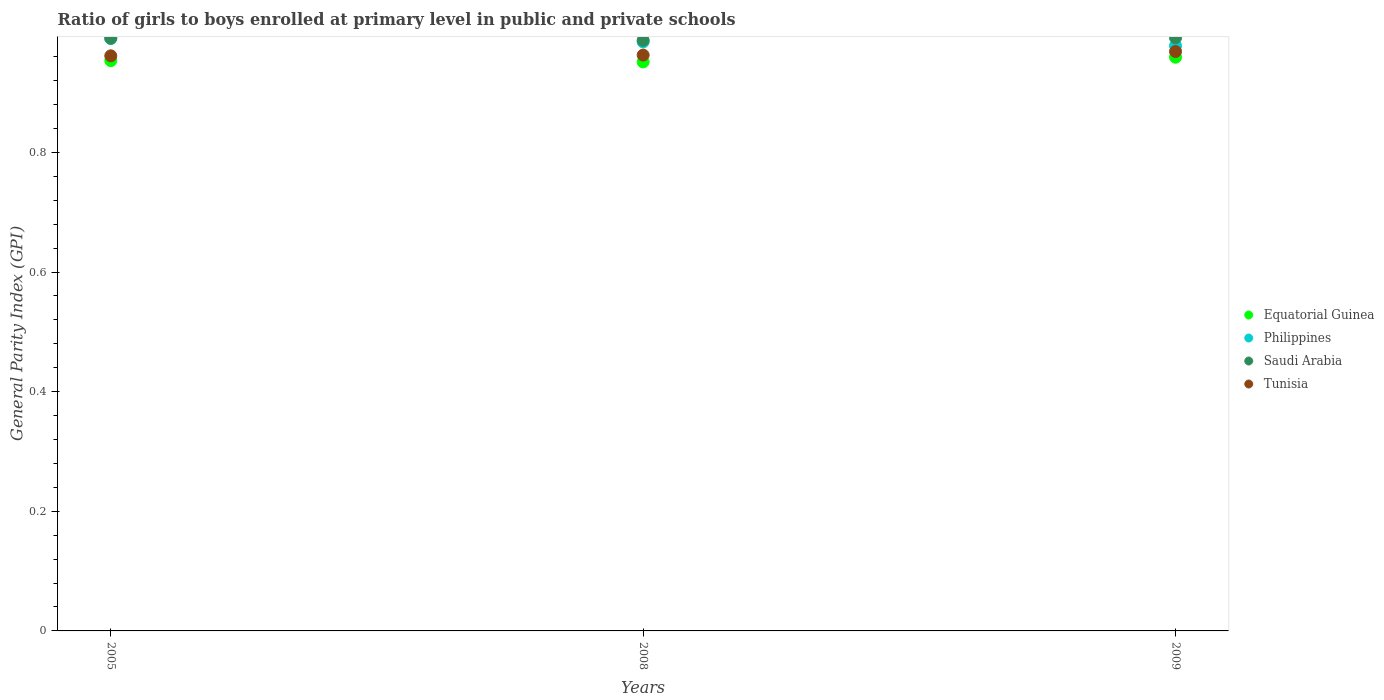How many different coloured dotlines are there?
Your response must be concise. 4. What is the general parity index in Saudi Arabia in 2005?
Your answer should be compact. 0.99. Across all years, what is the maximum general parity index in Philippines?
Your answer should be very brief. 0.99. Across all years, what is the minimum general parity index in Philippines?
Offer a terse response. 0.98. In which year was the general parity index in Equatorial Guinea minimum?
Keep it short and to the point. 2008. What is the total general parity index in Equatorial Guinea in the graph?
Provide a short and direct response. 2.86. What is the difference between the general parity index in Saudi Arabia in 2008 and that in 2009?
Your answer should be compact. -0. What is the difference between the general parity index in Philippines in 2005 and the general parity index in Equatorial Guinea in 2009?
Provide a succinct answer. 0.03. What is the average general parity index in Saudi Arabia per year?
Your response must be concise. 0.99. In the year 2005, what is the difference between the general parity index in Saudi Arabia and general parity index in Tunisia?
Your response must be concise. 0.03. In how many years, is the general parity index in Tunisia greater than 0.44?
Give a very brief answer. 3. What is the ratio of the general parity index in Tunisia in 2005 to that in 2008?
Ensure brevity in your answer.  1. What is the difference between the highest and the second highest general parity index in Saudi Arabia?
Make the answer very short. 0. What is the difference between the highest and the lowest general parity index in Equatorial Guinea?
Make the answer very short. 0.01. Is the sum of the general parity index in Philippines in 2005 and 2009 greater than the maximum general parity index in Tunisia across all years?
Your answer should be very brief. Yes. Is it the case that in every year, the sum of the general parity index in Tunisia and general parity index in Equatorial Guinea  is greater than the sum of general parity index in Saudi Arabia and general parity index in Philippines?
Make the answer very short. No. Is it the case that in every year, the sum of the general parity index in Equatorial Guinea and general parity index in Saudi Arabia  is greater than the general parity index in Philippines?
Ensure brevity in your answer.  Yes. Does the general parity index in Philippines monotonically increase over the years?
Offer a very short reply. No. Is the general parity index in Equatorial Guinea strictly greater than the general parity index in Saudi Arabia over the years?
Your answer should be compact. No. How many dotlines are there?
Your answer should be very brief. 4. How many years are there in the graph?
Your answer should be very brief. 3. Does the graph contain grids?
Give a very brief answer. No. Where does the legend appear in the graph?
Offer a terse response. Center right. What is the title of the graph?
Offer a very short reply. Ratio of girls to boys enrolled at primary level in public and private schools. What is the label or title of the X-axis?
Make the answer very short. Years. What is the label or title of the Y-axis?
Your answer should be very brief. General Parity Index (GPI). What is the General Parity Index (GPI) in Equatorial Guinea in 2005?
Give a very brief answer. 0.95. What is the General Parity Index (GPI) of Philippines in 2005?
Your answer should be very brief. 0.99. What is the General Parity Index (GPI) of Saudi Arabia in 2005?
Provide a short and direct response. 0.99. What is the General Parity Index (GPI) in Tunisia in 2005?
Ensure brevity in your answer.  0.96. What is the General Parity Index (GPI) of Equatorial Guinea in 2008?
Ensure brevity in your answer.  0.95. What is the General Parity Index (GPI) of Philippines in 2008?
Make the answer very short. 0.98. What is the General Parity Index (GPI) in Saudi Arabia in 2008?
Offer a very short reply. 0.99. What is the General Parity Index (GPI) in Tunisia in 2008?
Give a very brief answer. 0.96. What is the General Parity Index (GPI) in Equatorial Guinea in 2009?
Provide a succinct answer. 0.96. What is the General Parity Index (GPI) in Philippines in 2009?
Offer a very short reply. 0.98. What is the General Parity Index (GPI) in Saudi Arabia in 2009?
Keep it short and to the point. 0.99. What is the General Parity Index (GPI) in Tunisia in 2009?
Your answer should be compact. 0.97. Across all years, what is the maximum General Parity Index (GPI) of Equatorial Guinea?
Make the answer very short. 0.96. Across all years, what is the maximum General Parity Index (GPI) of Philippines?
Your response must be concise. 0.99. Across all years, what is the maximum General Parity Index (GPI) of Saudi Arabia?
Provide a short and direct response. 0.99. Across all years, what is the maximum General Parity Index (GPI) in Tunisia?
Make the answer very short. 0.97. Across all years, what is the minimum General Parity Index (GPI) of Equatorial Guinea?
Give a very brief answer. 0.95. Across all years, what is the minimum General Parity Index (GPI) of Philippines?
Provide a short and direct response. 0.98. Across all years, what is the minimum General Parity Index (GPI) of Saudi Arabia?
Give a very brief answer. 0.99. Across all years, what is the minimum General Parity Index (GPI) in Tunisia?
Provide a succinct answer. 0.96. What is the total General Parity Index (GPI) in Equatorial Guinea in the graph?
Give a very brief answer. 2.86. What is the total General Parity Index (GPI) in Philippines in the graph?
Ensure brevity in your answer.  2.95. What is the total General Parity Index (GPI) in Saudi Arabia in the graph?
Offer a very short reply. 2.97. What is the total General Parity Index (GPI) of Tunisia in the graph?
Your response must be concise. 2.89. What is the difference between the General Parity Index (GPI) in Equatorial Guinea in 2005 and that in 2008?
Make the answer very short. 0. What is the difference between the General Parity Index (GPI) in Philippines in 2005 and that in 2008?
Offer a terse response. 0.01. What is the difference between the General Parity Index (GPI) in Saudi Arabia in 2005 and that in 2008?
Keep it short and to the point. 0. What is the difference between the General Parity Index (GPI) in Tunisia in 2005 and that in 2008?
Provide a succinct answer. -0. What is the difference between the General Parity Index (GPI) in Equatorial Guinea in 2005 and that in 2009?
Offer a very short reply. -0.01. What is the difference between the General Parity Index (GPI) of Philippines in 2005 and that in 2009?
Ensure brevity in your answer.  0.01. What is the difference between the General Parity Index (GPI) of Saudi Arabia in 2005 and that in 2009?
Provide a succinct answer. -0. What is the difference between the General Parity Index (GPI) in Tunisia in 2005 and that in 2009?
Offer a very short reply. -0.01. What is the difference between the General Parity Index (GPI) in Equatorial Guinea in 2008 and that in 2009?
Give a very brief answer. -0.01. What is the difference between the General Parity Index (GPI) in Philippines in 2008 and that in 2009?
Offer a terse response. 0.01. What is the difference between the General Parity Index (GPI) of Saudi Arabia in 2008 and that in 2009?
Keep it short and to the point. -0. What is the difference between the General Parity Index (GPI) in Tunisia in 2008 and that in 2009?
Make the answer very short. -0.01. What is the difference between the General Parity Index (GPI) in Equatorial Guinea in 2005 and the General Parity Index (GPI) in Philippines in 2008?
Offer a terse response. -0.03. What is the difference between the General Parity Index (GPI) in Equatorial Guinea in 2005 and the General Parity Index (GPI) in Saudi Arabia in 2008?
Keep it short and to the point. -0.03. What is the difference between the General Parity Index (GPI) of Equatorial Guinea in 2005 and the General Parity Index (GPI) of Tunisia in 2008?
Provide a short and direct response. -0.01. What is the difference between the General Parity Index (GPI) in Philippines in 2005 and the General Parity Index (GPI) in Saudi Arabia in 2008?
Keep it short and to the point. 0. What is the difference between the General Parity Index (GPI) of Philippines in 2005 and the General Parity Index (GPI) of Tunisia in 2008?
Offer a very short reply. 0.03. What is the difference between the General Parity Index (GPI) in Saudi Arabia in 2005 and the General Parity Index (GPI) in Tunisia in 2008?
Make the answer very short. 0.03. What is the difference between the General Parity Index (GPI) of Equatorial Guinea in 2005 and the General Parity Index (GPI) of Philippines in 2009?
Keep it short and to the point. -0.02. What is the difference between the General Parity Index (GPI) of Equatorial Guinea in 2005 and the General Parity Index (GPI) of Saudi Arabia in 2009?
Provide a succinct answer. -0.04. What is the difference between the General Parity Index (GPI) of Equatorial Guinea in 2005 and the General Parity Index (GPI) of Tunisia in 2009?
Keep it short and to the point. -0.02. What is the difference between the General Parity Index (GPI) of Philippines in 2005 and the General Parity Index (GPI) of Saudi Arabia in 2009?
Your answer should be very brief. -0. What is the difference between the General Parity Index (GPI) in Philippines in 2005 and the General Parity Index (GPI) in Tunisia in 2009?
Offer a terse response. 0.02. What is the difference between the General Parity Index (GPI) in Saudi Arabia in 2005 and the General Parity Index (GPI) in Tunisia in 2009?
Your answer should be compact. 0.02. What is the difference between the General Parity Index (GPI) of Equatorial Guinea in 2008 and the General Parity Index (GPI) of Philippines in 2009?
Give a very brief answer. -0.03. What is the difference between the General Parity Index (GPI) in Equatorial Guinea in 2008 and the General Parity Index (GPI) in Saudi Arabia in 2009?
Give a very brief answer. -0.04. What is the difference between the General Parity Index (GPI) of Equatorial Guinea in 2008 and the General Parity Index (GPI) of Tunisia in 2009?
Your answer should be very brief. -0.02. What is the difference between the General Parity Index (GPI) in Philippines in 2008 and the General Parity Index (GPI) in Saudi Arabia in 2009?
Make the answer very short. -0.01. What is the difference between the General Parity Index (GPI) in Philippines in 2008 and the General Parity Index (GPI) in Tunisia in 2009?
Make the answer very short. 0.02. What is the difference between the General Parity Index (GPI) of Saudi Arabia in 2008 and the General Parity Index (GPI) of Tunisia in 2009?
Offer a very short reply. 0.02. What is the average General Parity Index (GPI) in Equatorial Guinea per year?
Make the answer very short. 0.95. What is the average General Parity Index (GPI) in Philippines per year?
Provide a short and direct response. 0.98. What is the average General Parity Index (GPI) in Tunisia per year?
Give a very brief answer. 0.96. In the year 2005, what is the difference between the General Parity Index (GPI) of Equatorial Guinea and General Parity Index (GPI) of Philippines?
Keep it short and to the point. -0.04. In the year 2005, what is the difference between the General Parity Index (GPI) in Equatorial Guinea and General Parity Index (GPI) in Saudi Arabia?
Give a very brief answer. -0.04. In the year 2005, what is the difference between the General Parity Index (GPI) of Equatorial Guinea and General Parity Index (GPI) of Tunisia?
Keep it short and to the point. -0.01. In the year 2005, what is the difference between the General Parity Index (GPI) of Philippines and General Parity Index (GPI) of Saudi Arabia?
Offer a very short reply. -0. In the year 2005, what is the difference between the General Parity Index (GPI) in Philippines and General Parity Index (GPI) in Tunisia?
Offer a very short reply. 0.03. In the year 2005, what is the difference between the General Parity Index (GPI) in Saudi Arabia and General Parity Index (GPI) in Tunisia?
Make the answer very short. 0.03. In the year 2008, what is the difference between the General Parity Index (GPI) of Equatorial Guinea and General Parity Index (GPI) of Philippines?
Your answer should be compact. -0.03. In the year 2008, what is the difference between the General Parity Index (GPI) in Equatorial Guinea and General Parity Index (GPI) in Saudi Arabia?
Provide a short and direct response. -0.04. In the year 2008, what is the difference between the General Parity Index (GPI) in Equatorial Guinea and General Parity Index (GPI) in Tunisia?
Make the answer very short. -0.01. In the year 2008, what is the difference between the General Parity Index (GPI) of Philippines and General Parity Index (GPI) of Saudi Arabia?
Offer a very short reply. -0. In the year 2008, what is the difference between the General Parity Index (GPI) of Philippines and General Parity Index (GPI) of Tunisia?
Offer a terse response. 0.02. In the year 2008, what is the difference between the General Parity Index (GPI) in Saudi Arabia and General Parity Index (GPI) in Tunisia?
Provide a succinct answer. 0.02. In the year 2009, what is the difference between the General Parity Index (GPI) in Equatorial Guinea and General Parity Index (GPI) in Philippines?
Offer a terse response. -0.02. In the year 2009, what is the difference between the General Parity Index (GPI) of Equatorial Guinea and General Parity Index (GPI) of Saudi Arabia?
Provide a succinct answer. -0.03. In the year 2009, what is the difference between the General Parity Index (GPI) in Equatorial Guinea and General Parity Index (GPI) in Tunisia?
Offer a terse response. -0.01. In the year 2009, what is the difference between the General Parity Index (GPI) in Philippines and General Parity Index (GPI) in Saudi Arabia?
Offer a terse response. -0.01. In the year 2009, what is the difference between the General Parity Index (GPI) of Philippines and General Parity Index (GPI) of Tunisia?
Provide a succinct answer. 0.01. In the year 2009, what is the difference between the General Parity Index (GPI) in Saudi Arabia and General Parity Index (GPI) in Tunisia?
Your response must be concise. 0.02. What is the ratio of the General Parity Index (GPI) of Equatorial Guinea in 2005 to that in 2008?
Ensure brevity in your answer.  1. What is the ratio of the General Parity Index (GPI) of Tunisia in 2005 to that in 2008?
Ensure brevity in your answer.  1. What is the ratio of the General Parity Index (GPI) in Philippines in 2005 to that in 2009?
Give a very brief answer. 1.01. What is the ratio of the General Parity Index (GPI) in Equatorial Guinea in 2008 to that in 2009?
Make the answer very short. 0.99. What is the ratio of the General Parity Index (GPI) of Philippines in 2008 to that in 2009?
Provide a succinct answer. 1.01. What is the difference between the highest and the second highest General Parity Index (GPI) in Equatorial Guinea?
Your answer should be compact. 0.01. What is the difference between the highest and the second highest General Parity Index (GPI) in Philippines?
Your answer should be compact. 0.01. What is the difference between the highest and the second highest General Parity Index (GPI) of Saudi Arabia?
Give a very brief answer. 0. What is the difference between the highest and the second highest General Parity Index (GPI) in Tunisia?
Ensure brevity in your answer.  0.01. What is the difference between the highest and the lowest General Parity Index (GPI) in Equatorial Guinea?
Your answer should be very brief. 0.01. What is the difference between the highest and the lowest General Parity Index (GPI) in Philippines?
Provide a short and direct response. 0.01. What is the difference between the highest and the lowest General Parity Index (GPI) of Saudi Arabia?
Offer a terse response. 0. What is the difference between the highest and the lowest General Parity Index (GPI) of Tunisia?
Provide a short and direct response. 0.01. 